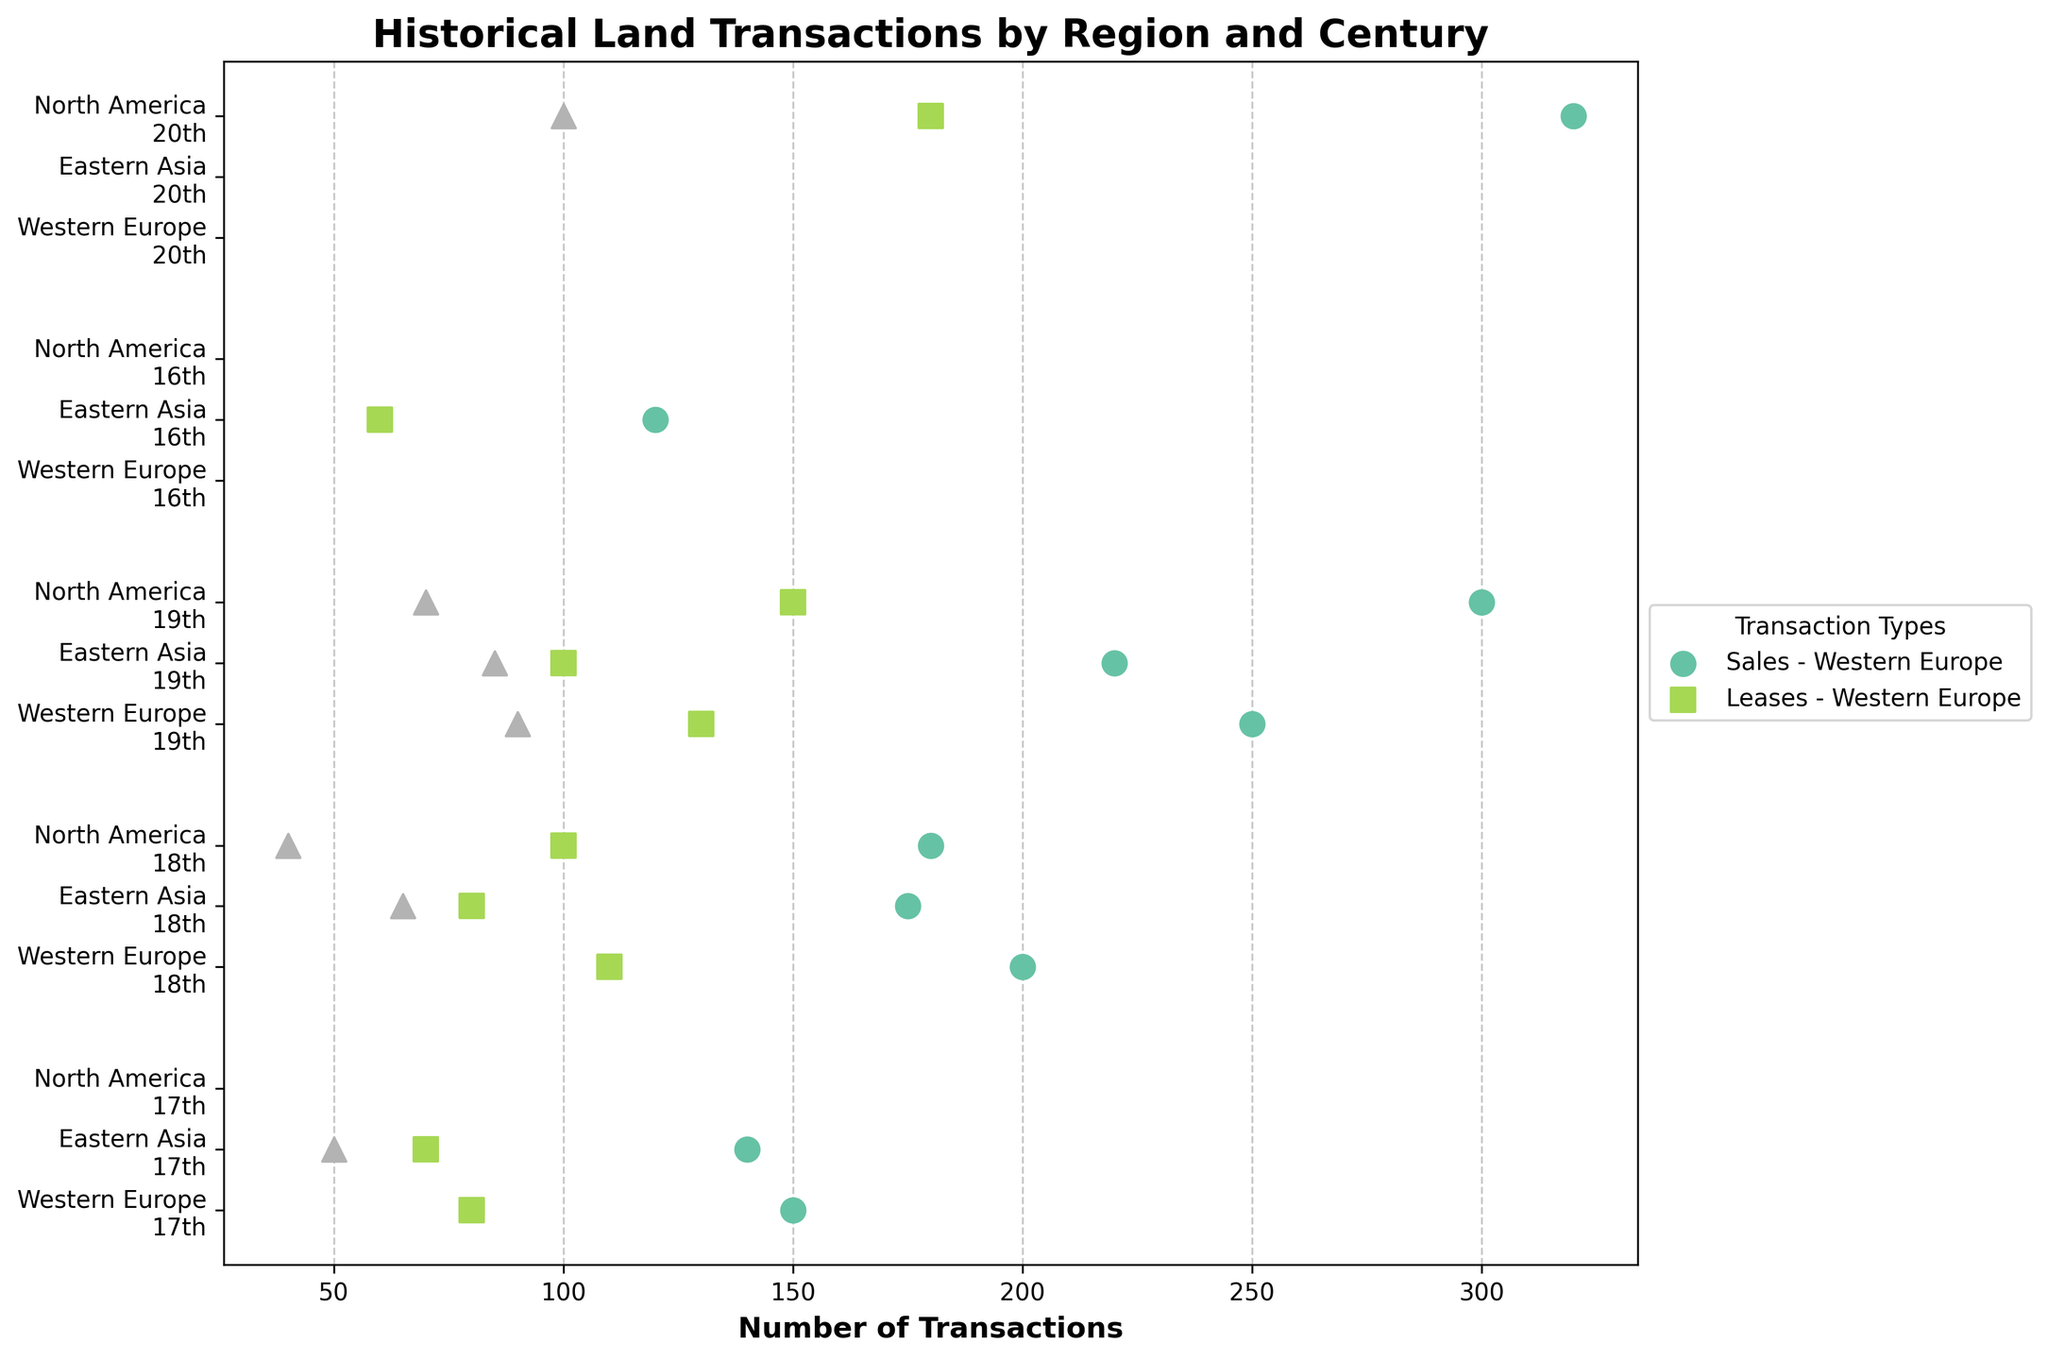What are the main colors used in the plot to represent different transaction types? The main colors used in the plot represent different transaction types based on a categorical colormap. Each type of transaction (Sales, Leases, Inheritances) is given a distinct color. Based on common palettes, colors could include shades like green, blue, and red. Observe the plot's legend to identify these colors.
Answer: Varies What is the trend of lease transactions in Western Europe from the 17th to the 19th century? In Western Europe, the number of lease transactions increased over the centuries. Specifically, there were 80 in the 17th century, 110 in the 18th century, and 130 in the 19th century, showing an upward trend.
Answer: Increasing Which region had the highest number of sales transactions in the 19th century? To identify the region with the highest number of sales transactions in the 19th century, look at the scatter points for each region in that century's row. North America had the highest count with 300 sales transactions.
Answer: North America Compare the lease transactions between North America in the 20th century and Eastern Asia in the 19th century. Which region had more leases? North America had 180 lease transactions in the 20th century, while Eastern Asia had 100 lease transactions in the 19th century. By comparing these two values, North America had more leases.
Answer: North America What is the sum of sales transactions in Eastern Asia over the 16th and 17th centuries? Sum the sales transactions for Eastern Asia in the 16th and 17th centuries. These values are 120 (16th) and 140 (17th). Adding them gives 120 + 140 = 260.
Answer: 260 How does the number of inheritance transactions in North America change from the 18th to the 20th century? Observe the data points for inheritances in North America across the 18th, 19th, and 20th centuries. The counts are 40 (18th), 70 (19th), and 100 (20th). There is a steady increase over the centuries.
Answer: Increasing What is the difference between the number of sales transactions in Western Europe and Eastern Asia in the 18th century? For the 18th century, Western Europe had 200 sales transactions, and Eastern Asia had 175 sales transactions. The difference is 200 - 175 = 25.
Answer: 25 Which type of transaction appears least frequently in the 17th century in Western Europe? The plot shows the counts for each transaction type in the 17th century for Western Europe. The least frequent type, with a count of 80, is leases.
Answer: Leases What is the median count of lease transactions in the 19th century across all regions? Find the counts of lease transactions in the 19th century for all regions: Western Europe (130), Eastern Asia (100), North America (150). Arrange them as 100, 130, 150. The median value is the middle one, which is 130.
Answer: 130 